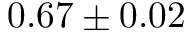Convert formula to latex. <formula><loc_0><loc_0><loc_500><loc_500>0 . 6 7 \pm 0 . 0 2</formula> 